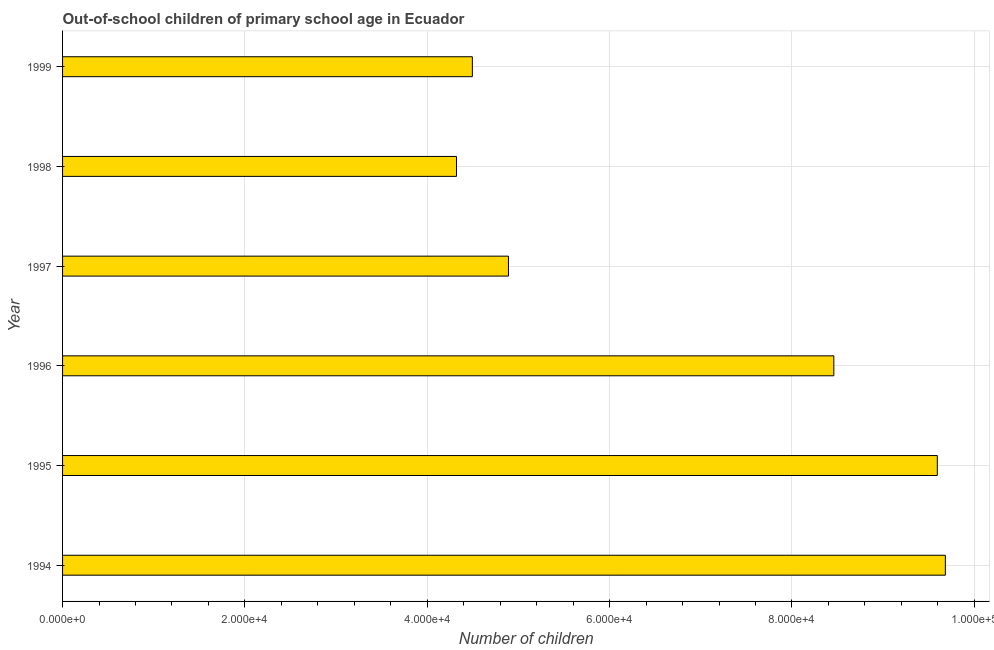Does the graph contain any zero values?
Offer a very short reply. No. What is the title of the graph?
Make the answer very short. Out-of-school children of primary school age in Ecuador. What is the label or title of the X-axis?
Your response must be concise. Number of children. What is the label or title of the Y-axis?
Offer a very short reply. Year. What is the number of out-of-school children in 1995?
Give a very brief answer. 9.59e+04. Across all years, what is the maximum number of out-of-school children?
Make the answer very short. 9.68e+04. Across all years, what is the minimum number of out-of-school children?
Make the answer very short. 4.32e+04. In which year was the number of out-of-school children maximum?
Your answer should be very brief. 1994. What is the sum of the number of out-of-school children?
Your response must be concise. 4.14e+05. What is the difference between the number of out-of-school children in 1994 and 1996?
Give a very brief answer. 1.22e+04. What is the average number of out-of-school children per year?
Your answer should be very brief. 6.91e+04. What is the median number of out-of-school children?
Provide a succinct answer. 6.67e+04. In how many years, is the number of out-of-school children greater than 76000 ?
Keep it short and to the point. 3. Do a majority of the years between 1998 and 1994 (inclusive) have number of out-of-school children greater than 44000 ?
Your answer should be very brief. Yes. What is the ratio of the number of out-of-school children in 1996 to that in 1997?
Ensure brevity in your answer.  1.73. Is the number of out-of-school children in 1996 less than that in 1999?
Provide a short and direct response. No. What is the difference between the highest and the second highest number of out-of-school children?
Provide a short and direct response. 880. Is the sum of the number of out-of-school children in 1995 and 1996 greater than the maximum number of out-of-school children across all years?
Provide a succinct answer. Yes. What is the difference between the highest and the lowest number of out-of-school children?
Keep it short and to the point. 5.36e+04. Are all the bars in the graph horizontal?
Keep it short and to the point. Yes. How many years are there in the graph?
Provide a succinct answer. 6. Are the values on the major ticks of X-axis written in scientific E-notation?
Offer a terse response. Yes. What is the Number of children of 1994?
Give a very brief answer. 9.68e+04. What is the Number of children in 1995?
Your response must be concise. 9.59e+04. What is the Number of children of 1996?
Your answer should be very brief. 8.46e+04. What is the Number of children in 1997?
Make the answer very short. 4.89e+04. What is the Number of children in 1998?
Your response must be concise. 4.32e+04. What is the Number of children of 1999?
Keep it short and to the point. 4.49e+04. What is the difference between the Number of children in 1994 and 1995?
Ensure brevity in your answer.  880. What is the difference between the Number of children in 1994 and 1996?
Provide a succinct answer. 1.22e+04. What is the difference between the Number of children in 1994 and 1997?
Offer a very short reply. 4.79e+04. What is the difference between the Number of children in 1994 and 1998?
Your response must be concise. 5.36e+04. What is the difference between the Number of children in 1994 and 1999?
Your answer should be compact. 5.19e+04. What is the difference between the Number of children in 1995 and 1996?
Make the answer very short. 1.14e+04. What is the difference between the Number of children in 1995 and 1997?
Offer a terse response. 4.70e+04. What is the difference between the Number of children in 1995 and 1998?
Keep it short and to the point. 5.27e+04. What is the difference between the Number of children in 1995 and 1999?
Make the answer very short. 5.10e+04. What is the difference between the Number of children in 1996 and 1997?
Your answer should be very brief. 3.57e+04. What is the difference between the Number of children in 1996 and 1998?
Your answer should be compact. 4.14e+04. What is the difference between the Number of children in 1996 and 1999?
Offer a terse response. 3.96e+04. What is the difference between the Number of children in 1997 and 1998?
Offer a very short reply. 5698. What is the difference between the Number of children in 1997 and 1999?
Give a very brief answer. 3959. What is the difference between the Number of children in 1998 and 1999?
Your answer should be very brief. -1739. What is the ratio of the Number of children in 1994 to that in 1996?
Provide a short and direct response. 1.15. What is the ratio of the Number of children in 1994 to that in 1997?
Make the answer very short. 1.98. What is the ratio of the Number of children in 1994 to that in 1998?
Your answer should be very brief. 2.24. What is the ratio of the Number of children in 1994 to that in 1999?
Make the answer very short. 2.15. What is the ratio of the Number of children in 1995 to that in 1996?
Keep it short and to the point. 1.13. What is the ratio of the Number of children in 1995 to that in 1997?
Your response must be concise. 1.96. What is the ratio of the Number of children in 1995 to that in 1998?
Your answer should be compact. 2.22. What is the ratio of the Number of children in 1995 to that in 1999?
Your response must be concise. 2.13. What is the ratio of the Number of children in 1996 to that in 1997?
Keep it short and to the point. 1.73. What is the ratio of the Number of children in 1996 to that in 1998?
Provide a succinct answer. 1.96. What is the ratio of the Number of children in 1996 to that in 1999?
Provide a short and direct response. 1.88. What is the ratio of the Number of children in 1997 to that in 1998?
Offer a terse response. 1.13. What is the ratio of the Number of children in 1997 to that in 1999?
Keep it short and to the point. 1.09. 